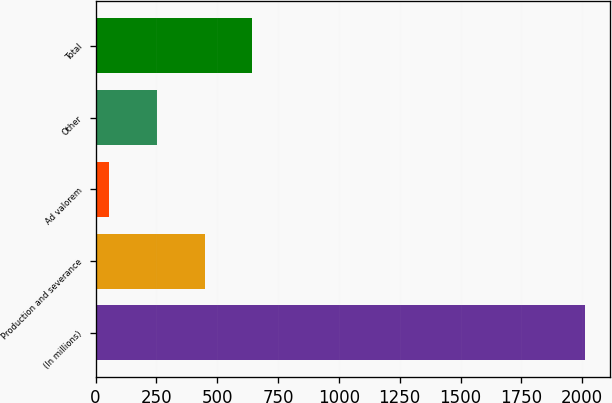Convert chart. <chart><loc_0><loc_0><loc_500><loc_500><bar_chart><fcel>(In millions)<fcel>Production and severance<fcel>Ad valorem<fcel>Other<fcel>Total<nl><fcel>2012<fcel>448<fcel>57<fcel>252.5<fcel>643.5<nl></chart> 